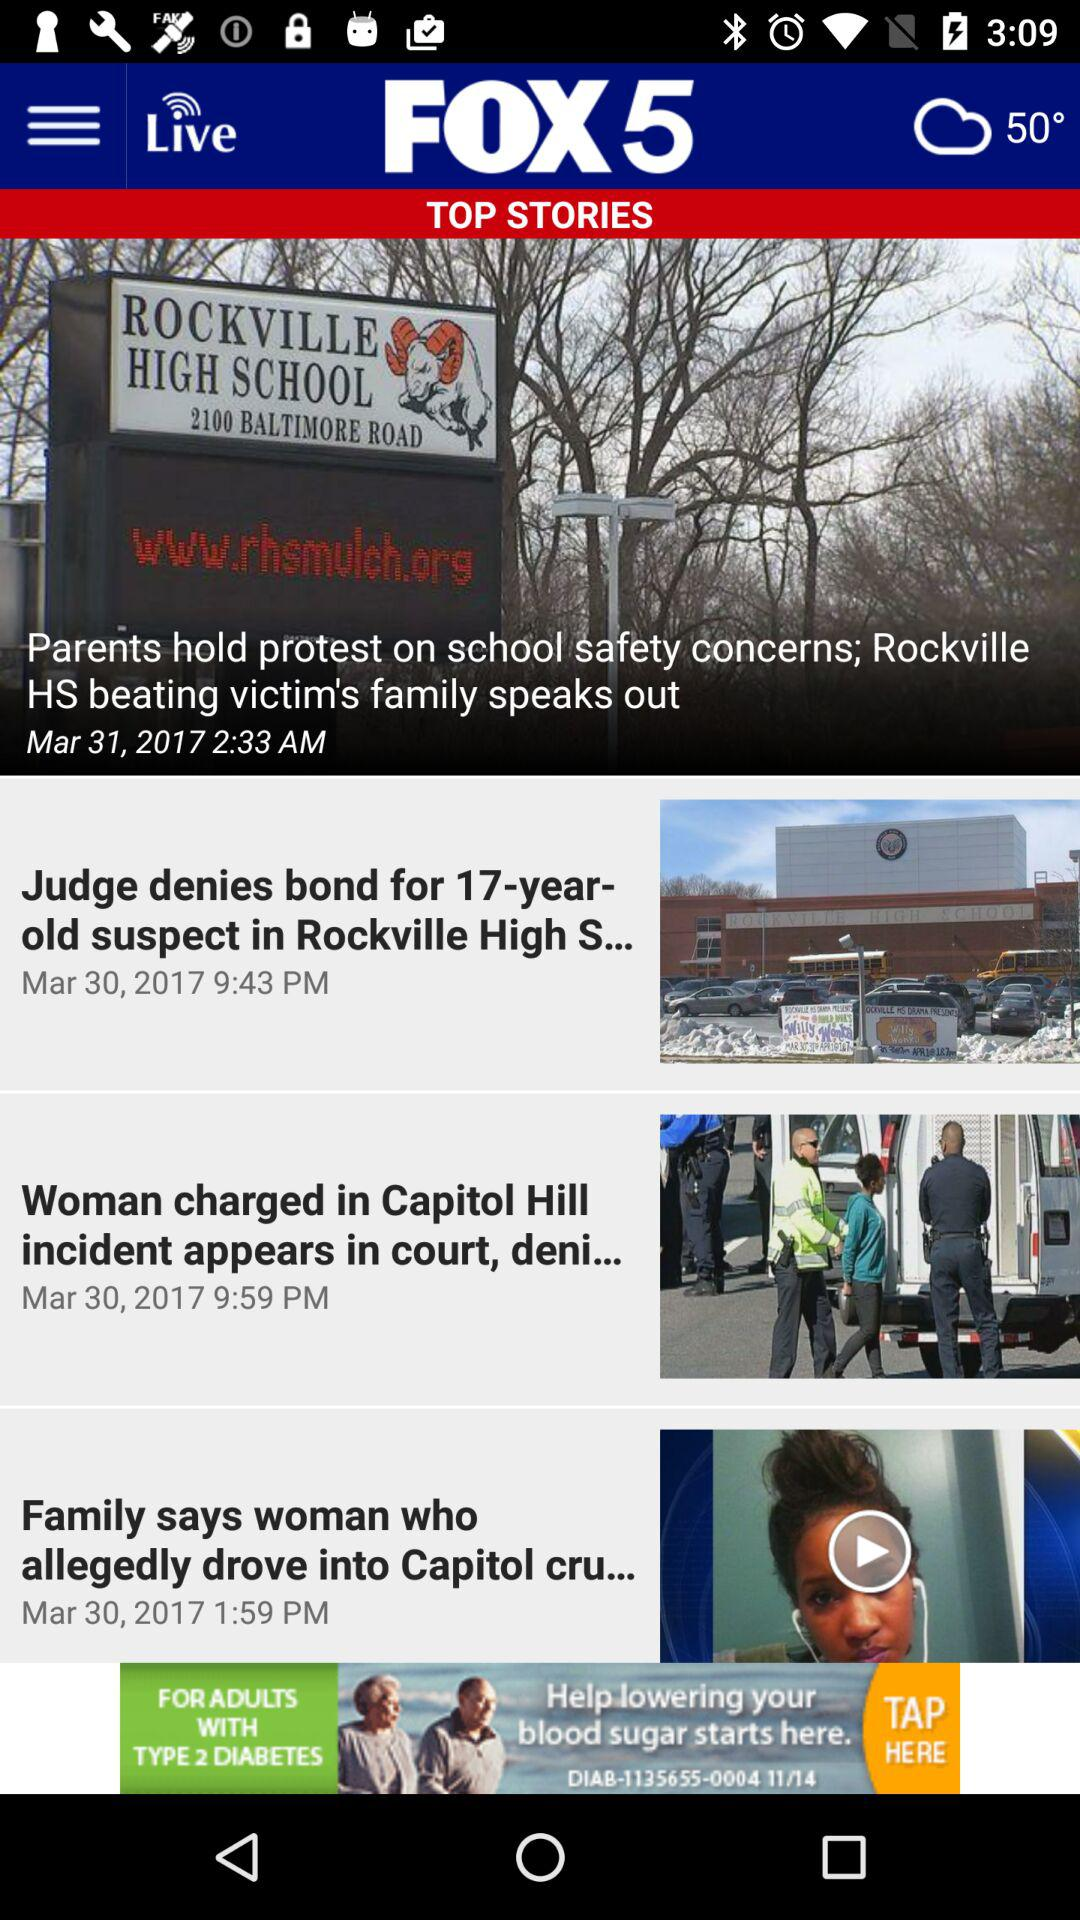At what time is the news about the "Woman charged in Capitol Hill incident appears in court" posted? The posted time is 9:59 PM. 